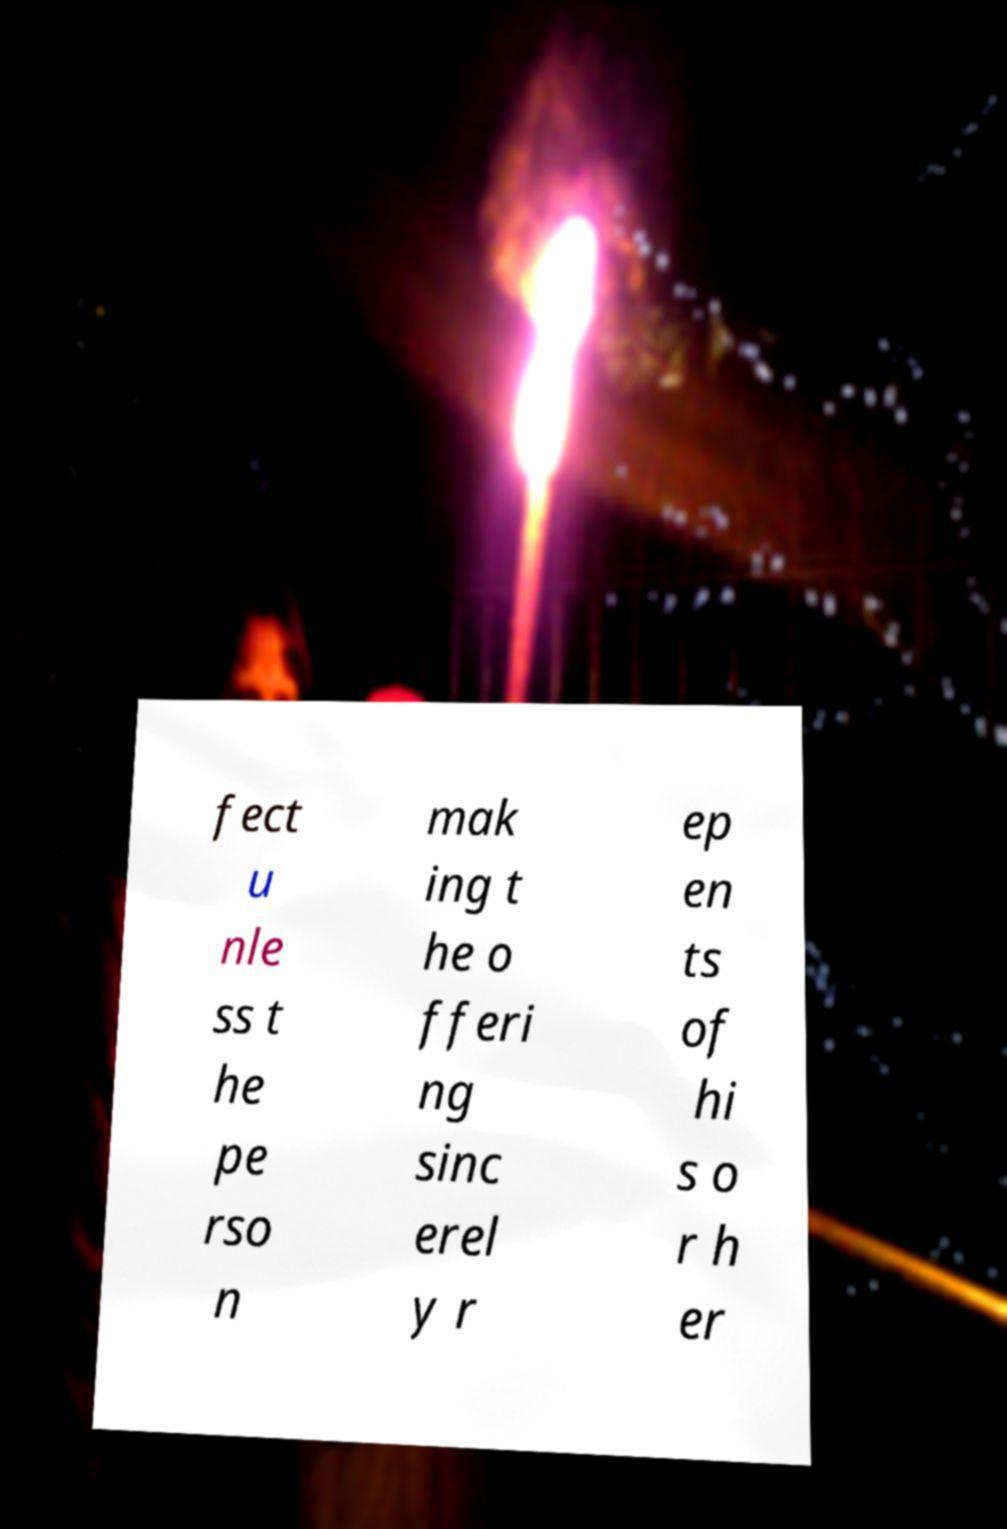Could you assist in decoding the text presented in this image and type it out clearly? fect u nle ss t he pe rso n mak ing t he o fferi ng sinc erel y r ep en ts of hi s o r h er 